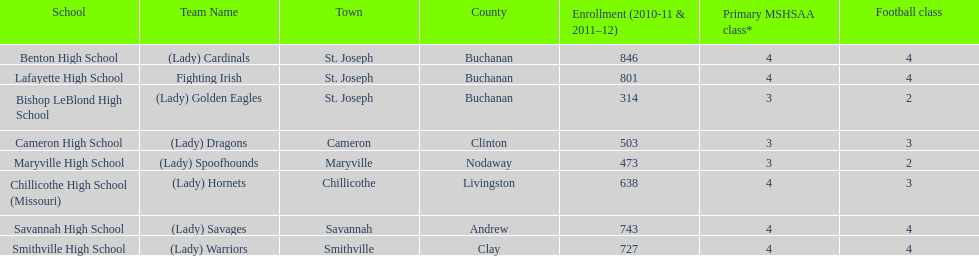In the 2010-2011 and 2011-2012 academic years, how many schools had a minimum enrollment of 500 students? 6. 